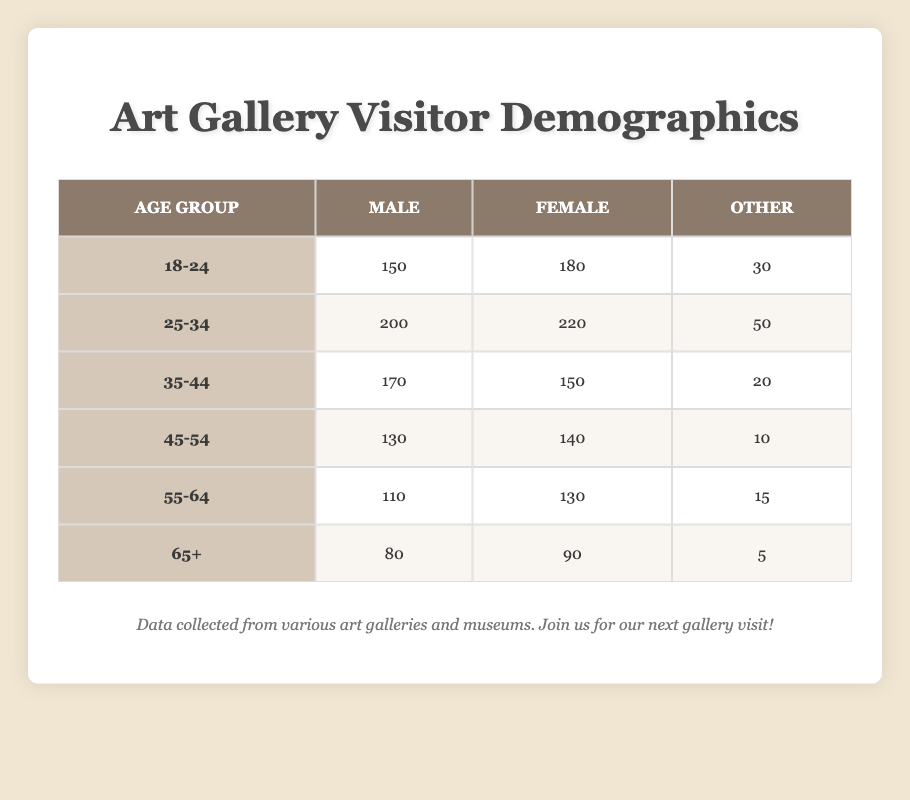What is the total number of visitors in the age group 25-34? To find the total number of visitors in this age group, I add the counts for Male (200), Female (220), and Other (50): 200 + 220 + 50 = 470.
Answer: 470 Which age group has the highest number of Female visitors? By comparing the Female visitor numbers across all age groups, 220 for the 25-34 age group is the highest, followed by 180 in 18-24.
Answer: 25-34 How many visitors identify as Other in the age group 55-64? The table indicates that in the 55-64 age group, the number of visitors identifying as Other is 15, as shown directly in the table.
Answer: 15 Is it true that more males than females visit in the age group 45-54? In the 45-54 age group, there are 130 Male visitors and 140 Female visitors, so it is false that more males visit.
Answer: No What is the average number of visitors across all age groups for each gender? To find the average, we need to sum each gender's counts from all age groups: Males (150+200+170+130+110+80 = 1040), Females (180+220+150+140+130+90 = 1110), and divide by 6 (the number of age groups). For Males, 1040 / 6 = 173.33 and for Females, 1110 / 6 = 185.
Answer: Male: 173.33, Female: 185 Which age group has the lowest number of visitors overall? To determine the age group with the lowest overall number of visitors, I will sum the numbers of all genders for each age group. The age group 65+ has a total of 80 (Male) + 90 (Female) + 5 (Other) = 175, which is lower than any other age group totals.
Answer: 65+ What is the difference in the number of Male visitors between the 25-34 and 35-44 age groups? The number of Male visitors in the 25-34 age group is 200, and in the 35-44 age group it is 170. The difference is 200 - 170 = 30.
Answer: 30 How many total Female visitors are there across all age groups? To find the total number of Female visitors, I sum the counts for each age group: 180 + 220 + 150 + 140 + 130 + 90 = 1110.
Answer: 1110 